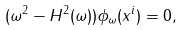<formula> <loc_0><loc_0><loc_500><loc_500>( \omega ^ { 2 } - H ^ { 2 } ( \omega ) ) \phi _ { \omega } ( x ^ { i } ) = 0 ,</formula> 